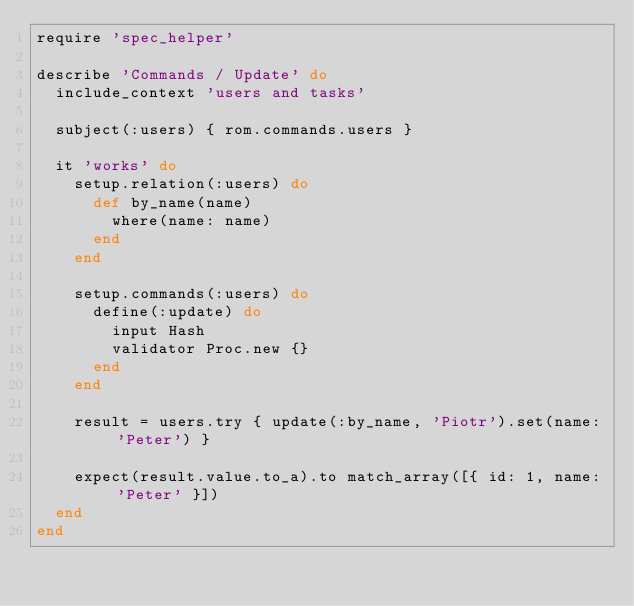<code> <loc_0><loc_0><loc_500><loc_500><_Ruby_>require 'spec_helper'

describe 'Commands / Update' do
  include_context 'users and tasks'

  subject(:users) { rom.commands.users }

  it 'works' do
    setup.relation(:users) do
      def by_name(name)
        where(name: name)
      end
    end

    setup.commands(:users) do
      define(:update) do
        input Hash
        validator Proc.new {}
      end
    end

    result = users.try { update(:by_name, 'Piotr').set(name: 'Peter') }

    expect(result.value.to_a).to match_array([{ id: 1, name: 'Peter' }])
  end
end
</code> 